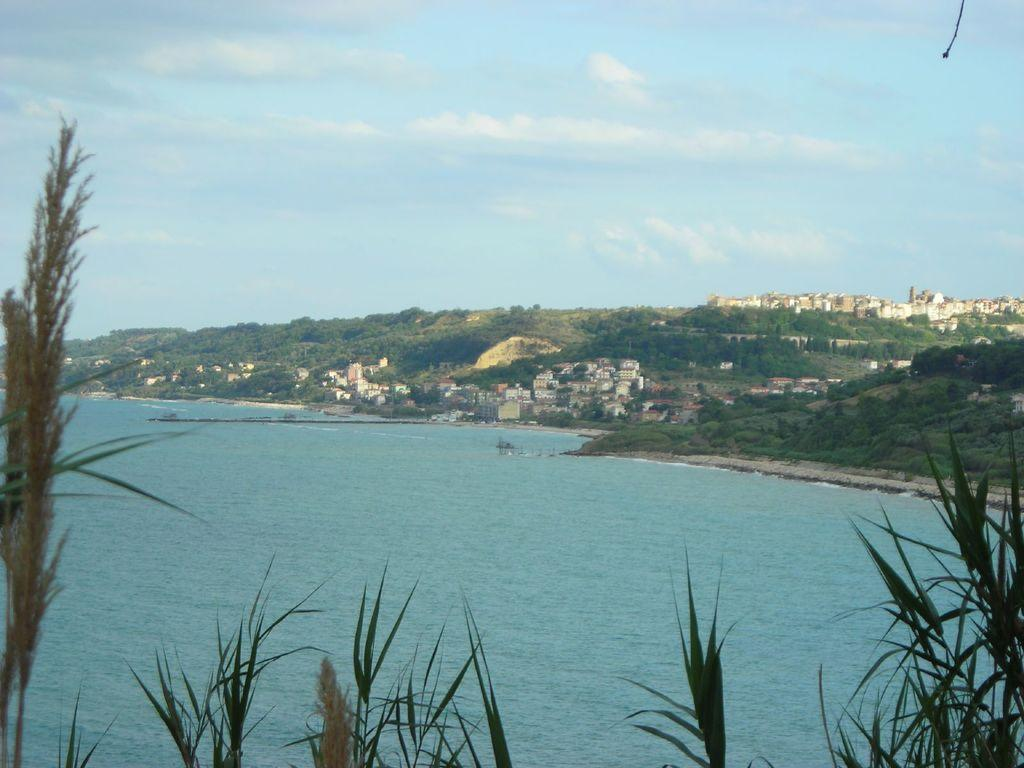What is located in the foreground of the image? There are plants in the foreground of the image. What can be seen in the image besides the plants? There is a water body, buildings, hills, and trees in the background of the image. What is the condition of the sky in the image? The sky is cloudy in the image. Are there any animals on vacation in the image? There is no information about animals or vacations in the image; it primarily features plants, a water body, buildings, hills, trees, and a cloudy sky. 